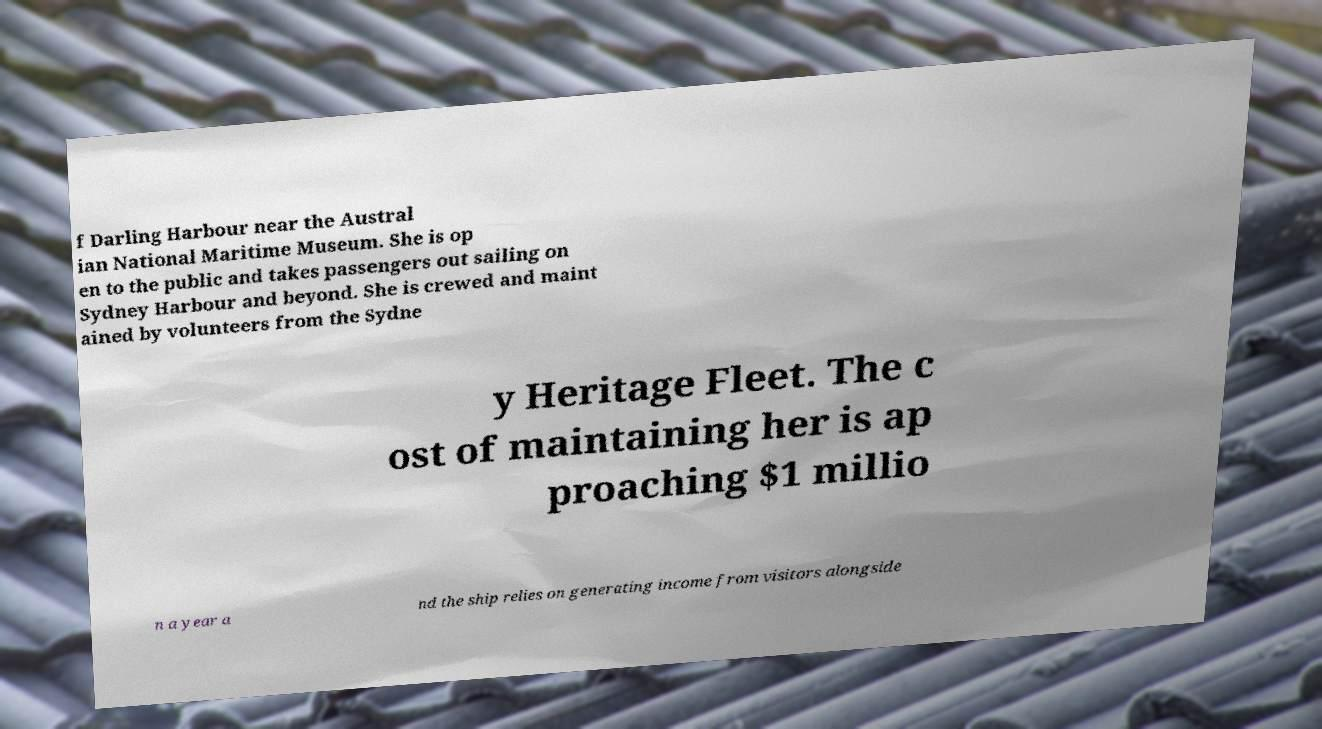Could you extract and type out the text from this image? f Darling Harbour near the Austral ian National Maritime Museum. She is op en to the public and takes passengers out sailing on Sydney Harbour and beyond. She is crewed and maint ained by volunteers from the Sydne y Heritage Fleet. The c ost of maintaining her is ap proaching $1 millio n a year a nd the ship relies on generating income from visitors alongside 